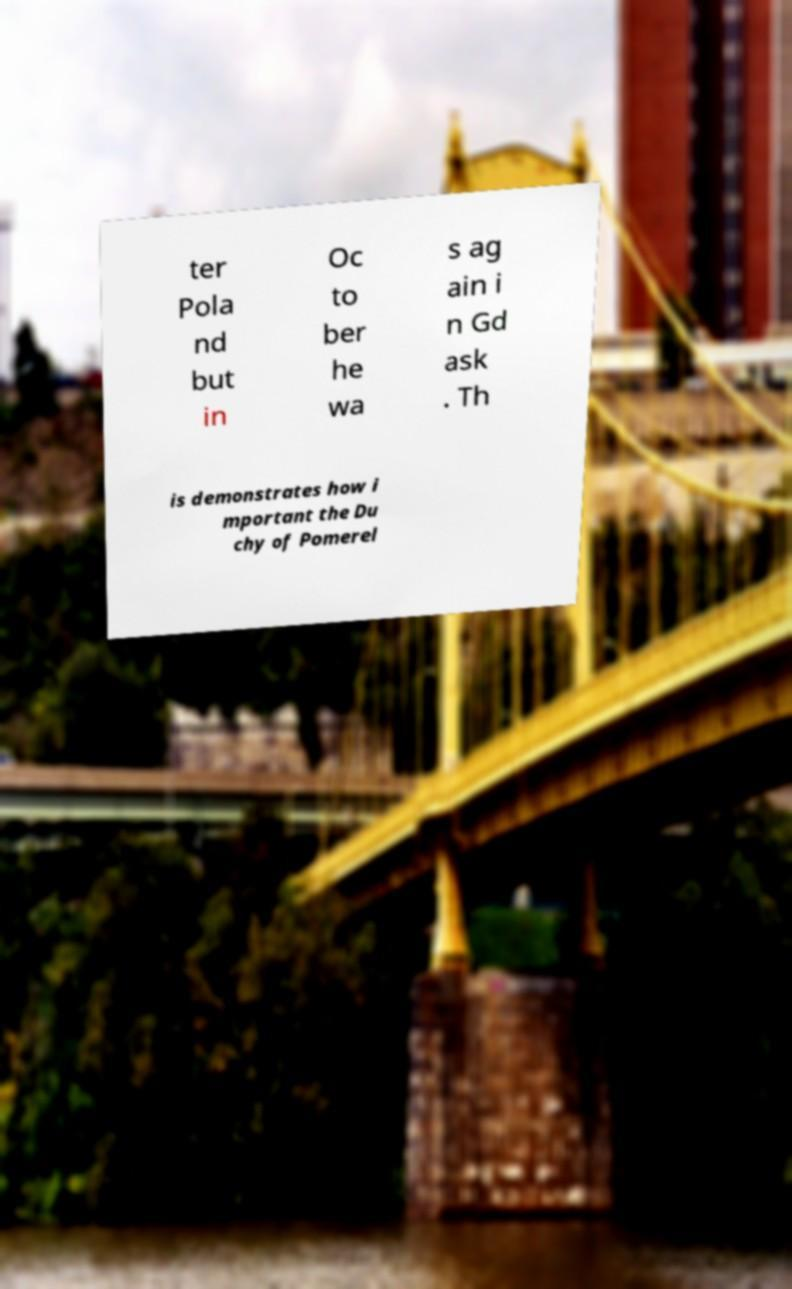Please identify and transcribe the text found in this image. ter Pola nd but in Oc to ber he wa s ag ain i n Gd ask . Th is demonstrates how i mportant the Du chy of Pomerel 